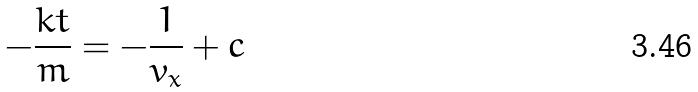Convert formula to latex. <formula><loc_0><loc_0><loc_500><loc_500>- \frac { k t } { m } = - \frac { 1 } { v _ { x } } + c</formula> 